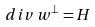Convert formula to latex. <formula><loc_0><loc_0><loc_500><loc_500>d i v \, w ^ { \perp } = H</formula> 